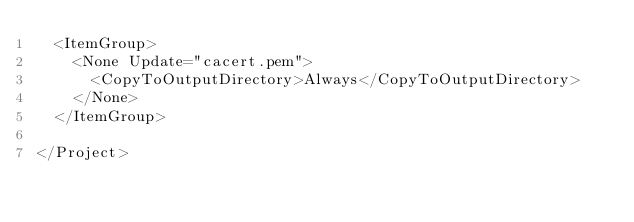Convert code to text. <code><loc_0><loc_0><loc_500><loc_500><_XML_>  <ItemGroup>
    <None Update="cacert.pem">
      <CopyToOutputDirectory>Always</CopyToOutputDirectory>
    </None>
  </ItemGroup>

</Project>
</code> 